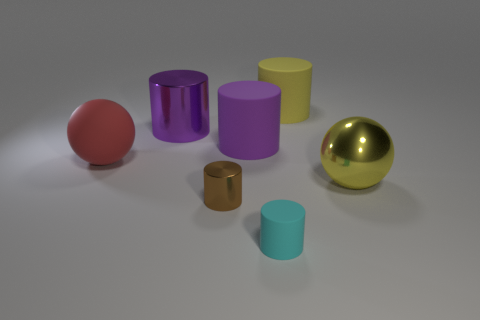What is the texture of the surface on which the objects are placed? The surface texture appears to be smooth with a matte finish, providing a subtle reflection and soft shadows under the objects, which suggests a non-reflective material. Could you guess the material of this surface? While it is difficult to ascertain the exact material without further information, the visual cues suggest it could be a type of matte plastic or painted wood typically used in product photography for a neutral background. 